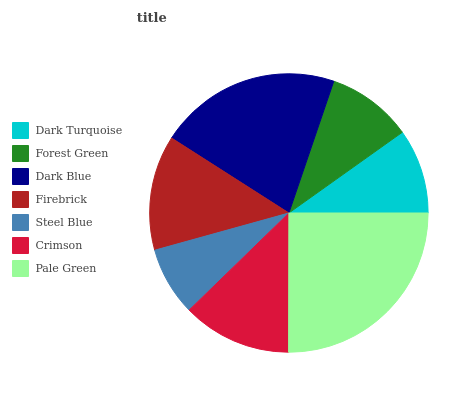Is Steel Blue the minimum?
Answer yes or no. Yes. Is Pale Green the maximum?
Answer yes or no. Yes. Is Forest Green the minimum?
Answer yes or no. No. Is Forest Green the maximum?
Answer yes or no. No. Is Forest Green greater than Dark Turquoise?
Answer yes or no. Yes. Is Dark Turquoise less than Forest Green?
Answer yes or no. Yes. Is Dark Turquoise greater than Forest Green?
Answer yes or no. No. Is Forest Green less than Dark Turquoise?
Answer yes or no. No. Is Crimson the high median?
Answer yes or no. Yes. Is Crimson the low median?
Answer yes or no. Yes. Is Firebrick the high median?
Answer yes or no. No. Is Pale Green the low median?
Answer yes or no. No. 